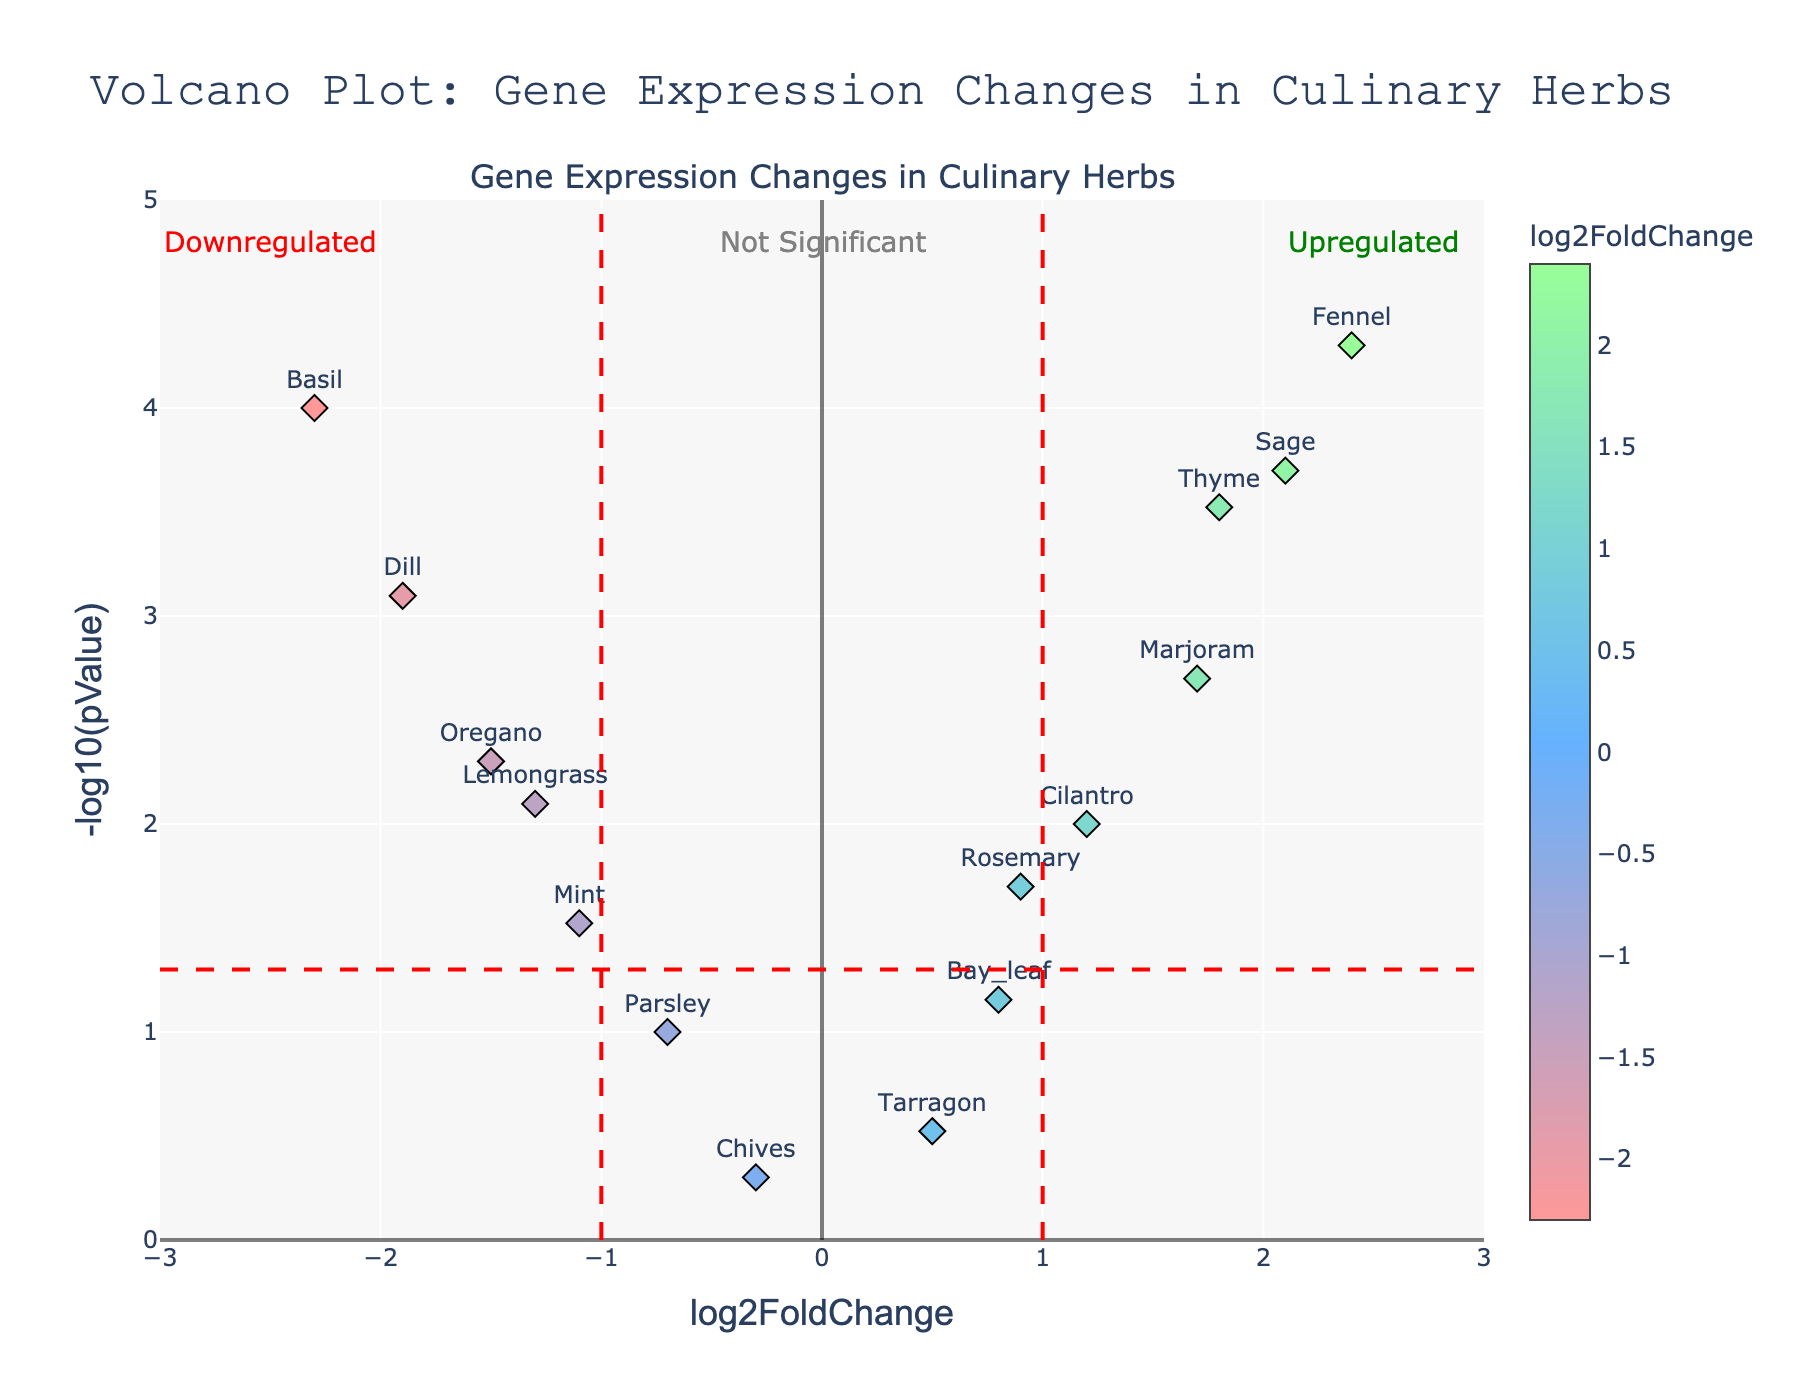How many herbs show statistically significant changes in gene expression? Statistically significant changes in gene expression are typically indicated by a p-value < 0.05. From the plot, we look for points above the red horizontal dashed line that separates significant from non-significant (y = -log10(0.05)). The herbs that are above this line are: Basil, Thyme, Oregano, Sage, Dill, Marjoram, Fennel, Lemongrass, and Cilantro.
Answer: 9 Which herb shows the biggest log2 fold change? The x-axis indicates the log2 fold change. The herb with the most extreme point along the x-axis shows the biggest fold change. This is Fennel, which is at x = 2.4.
Answer: Fennel Which herb has the smallest p-value? The smallest p-value will be represented by the highest point on the y-axis (since the y-axis is -log10(p-value)). The point furthest along the y-axis is Fennel. A corresponding high y-value means a very small p-value.
Answer: Fennel Are there more upregulated or downregulated herbs? Upregulated herbs have positive log2 fold change values (points on the right of x=0), while downregulated herbs have negative values (points on the left of x=0). From the plot, the upregulated herbs are: Thyme, Sage, Rosemary, Cilantro, Marjoram, Bay leaf, and Fennel. The downregulated herbs are: Basil, Oregano, Dill, Mint, Parsley, Chives, and Lemongrass. Count each group.
Answer: More upregulated (7 up vs 7 down) Which herbs are considered not significant based on their p-values? Herbs not significant will have their points below the horizontal significance threshold line (y = -log10(0.05)). These herbs are: Parsley, Rosemary, Tarragon, Chives, Bay leaf, and Mint.
Answer: Parsley, Rosemary, Tarragon, Chives, Bay leaf, Mint Which herb has the highest -log10(p-value)? The highest -log10(p-value) corresponds to the highest point on the y-axis. This point belongs to the herb Fennel.
Answer: Fennel Which herb has the lowest -log10(p-value)? The lowest value on the y-axis would be at the bottom of the plot. While examining the plot, the herb closest to the bottom is chives at approximately y = 0.3.
Answer: Chives How does the expression of Basil compare to Sage? We need to compare the positions of Basil and Sage on the plot. Basil has a negative log2 fold change and is to the left of x = 0, while Sage has a positive log2 fold change and is to the right of x = 0. Additionally, Basil has a lower p-value than Sage (hence a higher y-value).
Answer: Basil is downregulated, Sage is upregulated Which direction is Lemongrass regulated, and is this change significant? Lemongrass has a negative log2 fold change, placing it on the left side of the plot, indicating downregulation. To determine significance, we check vertical positioning relative to the horizontal significance line (y = -log10(0.05)). Lemongrass is above this line, meaning the change is significant.
Answer: Downregulated and significant 